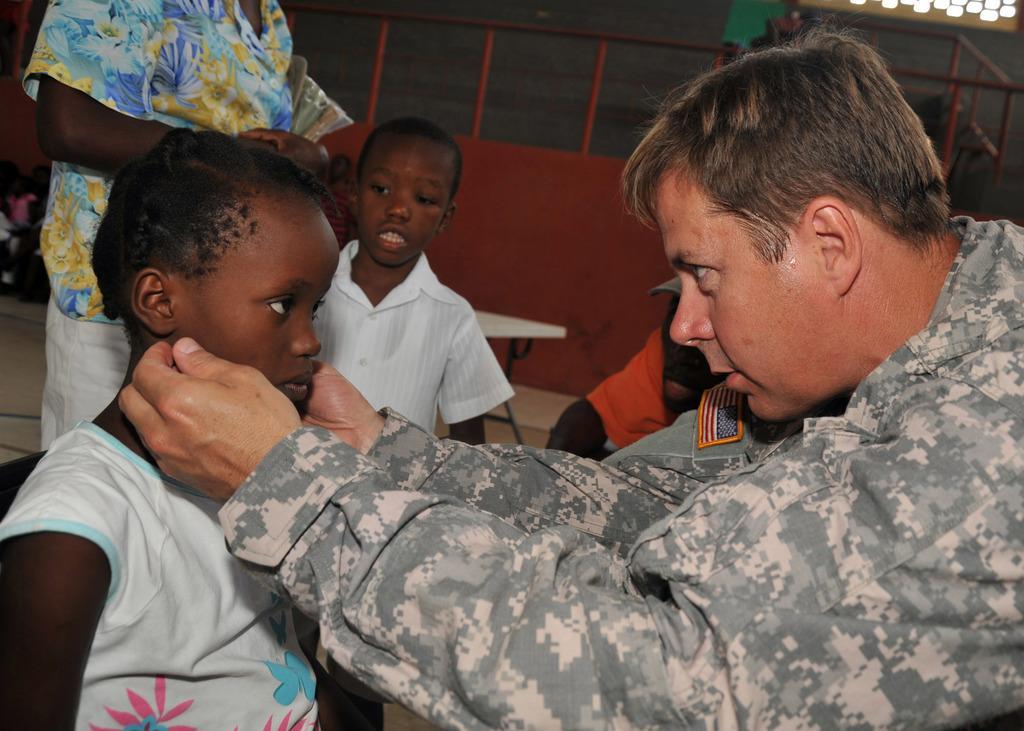Please provide a concise description of this image. In this image I can see the group of people with different color dresses and one person with the military uniform. In the background I can see the table and the red color metal object. 